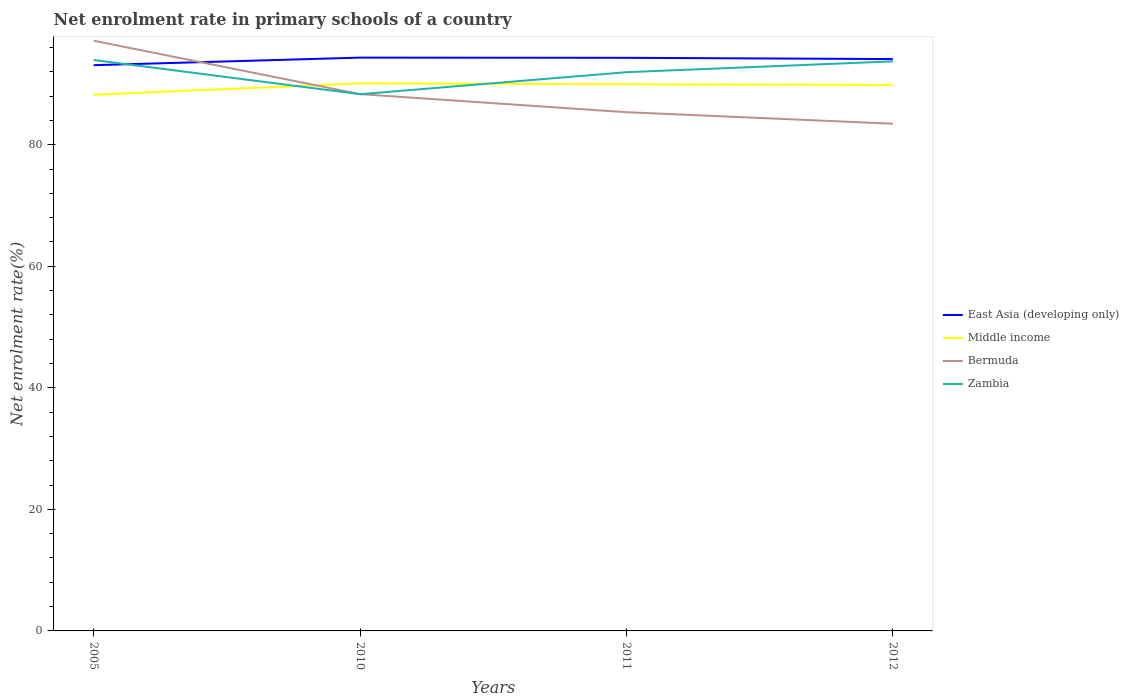Is the number of lines equal to the number of legend labels?
Your response must be concise. Yes. Across all years, what is the maximum net enrolment rate in primary schools in Zambia?
Ensure brevity in your answer.  88.31. What is the total net enrolment rate in primary schools in Middle income in the graph?
Provide a succinct answer. 0.12. What is the difference between the highest and the second highest net enrolment rate in primary schools in Zambia?
Your answer should be compact. 5.63. What is the difference between the highest and the lowest net enrolment rate in primary schools in East Asia (developing only)?
Ensure brevity in your answer.  3. Is the net enrolment rate in primary schools in Bermuda strictly greater than the net enrolment rate in primary schools in East Asia (developing only) over the years?
Your answer should be very brief. No. How many years are there in the graph?
Keep it short and to the point. 4. Are the values on the major ticks of Y-axis written in scientific E-notation?
Ensure brevity in your answer.  No. Where does the legend appear in the graph?
Provide a short and direct response. Center right. How are the legend labels stacked?
Ensure brevity in your answer.  Vertical. What is the title of the graph?
Make the answer very short. Net enrolment rate in primary schools of a country. What is the label or title of the X-axis?
Provide a succinct answer. Years. What is the label or title of the Y-axis?
Offer a very short reply. Net enrolment rate(%). What is the Net enrolment rate(%) of East Asia (developing only) in 2005?
Ensure brevity in your answer.  93.09. What is the Net enrolment rate(%) in Middle income in 2005?
Offer a very short reply. 88.22. What is the Net enrolment rate(%) of Bermuda in 2005?
Your response must be concise. 97.11. What is the Net enrolment rate(%) in Zambia in 2005?
Provide a short and direct response. 93.94. What is the Net enrolment rate(%) in East Asia (developing only) in 2010?
Keep it short and to the point. 94.33. What is the Net enrolment rate(%) in Middle income in 2010?
Your answer should be very brief. 90.09. What is the Net enrolment rate(%) of Bermuda in 2010?
Your answer should be compact. 88.32. What is the Net enrolment rate(%) of Zambia in 2010?
Offer a very short reply. 88.31. What is the Net enrolment rate(%) in East Asia (developing only) in 2011?
Your answer should be compact. 94.3. What is the Net enrolment rate(%) of Middle income in 2011?
Provide a succinct answer. 89.95. What is the Net enrolment rate(%) in Bermuda in 2011?
Your answer should be very brief. 85.35. What is the Net enrolment rate(%) in Zambia in 2011?
Provide a short and direct response. 91.93. What is the Net enrolment rate(%) in East Asia (developing only) in 2012?
Offer a terse response. 94.09. What is the Net enrolment rate(%) of Middle income in 2012?
Provide a short and direct response. 89.83. What is the Net enrolment rate(%) in Bermuda in 2012?
Your answer should be very brief. 83.46. What is the Net enrolment rate(%) in Zambia in 2012?
Keep it short and to the point. 93.72. Across all years, what is the maximum Net enrolment rate(%) in East Asia (developing only)?
Your answer should be compact. 94.33. Across all years, what is the maximum Net enrolment rate(%) in Middle income?
Give a very brief answer. 90.09. Across all years, what is the maximum Net enrolment rate(%) of Bermuda?
Keep it short and to the point. 97.11. Across all years, what is the maximum Net enrolment rate(%) of Zambia?
Provide a succinct answer. 93.94. Across all years, what is the minimum Net enrolment rate(%) in East Asia (developing only)?
Provide a short and direct response. 93.09. Across all years, what is the minimum Net enrolment rate(%) of Middle income?
Offer a very short reply. 88.22. Across all years, what is the minimum Net enrolment rate(%) in Bermuda?
Keep it short and to the point. 83.46. Across all years, what is the minimum Net enrolment rate(%) in Zambia?
Your answer should be compact. 88.31. What is the total Net enrolment rate(%) of East Asia (developing only) in the graph?
Your response must be concise. 375.81. What is the total Net enrolment rate(%) of Middle income in the graph?
Your response must be concise. 358.09. What is the total Net enrolment rate(%) in Bermuda in the graph?
Your answer should be very brief. 354.24. What is the total Net enrolment rate(%) in Zambia in the graph?
Offer a very short reply. 367.9. What is the difference between the Net enrolment rate(%) in East Asia (developing only) in 2005 and that in 2010?
Give a very brief answer. -1.24. What is the difference between the Net enrolment rate(%) in Middle income in 2005 and that in 2010?
Your answer should be compact. -1.87. What is the difference between the Net enrolment rate(%) in Bermuda in 2005 and that in 2010?
Offer a very short reply. 8.79. What is the difference between the Net enrolment rate(%) of Zambia in 2005 and that in 2010?
Offer a very short reply. 5.63. What is the difference between the Net enrolment rate(%) of East Asia (developing only) in 2005 and that in 2011?
Your response must be concise. -1.21. What is the difference between the Net enrolment rate(%) in Middle income in 2005 and that in 2011?
Provide a succinct answer. -1.73. What is the difference between the Net enrolment rate(%) in Bermuda in 2005 and that in 2011?
Your response must be concise. 11.76. What is the difference between the Net enrolment rate(%) of Zambia in 2005 and that in 2011?
Your answer should be compact. 2.01. What is the difference between the Net enrolment rate(%) of East Asia (developing only) in 2005 and that in 2012?
Keep it short and to the point. -1.01. What is the difference between the Net enrolment rate(%) of Middle income in 2005 and that in 2012?
Offer a terse response. -1.61. What is the difference between the Net enrolment rate(%) in Bermuda in 2005 and that in 2012?
Give a very brief answer. 13.65. What is the difference between the Net enrolment rate(%) in Zambia in 2005 and that in 2012?
Give a very brief answer. 0.22. What is the difference between the Net enrolment rate(%) in East Asia (developing only) in 2010 and that in 2011?
Ensure brevity in your answer.  0.03. What is the difference between the Net enrolment rate(%) of Middle income in 2010 and that in 2011?
Make the answer very short. 0.14. What is the difference between the Net enrolment rate(%) in Bermuda in 2010 and that in 2011?
Keep it short and to the point. 2.97. What is the difference between the Net enrolment rate(%) of Zambia in 2010 and that in 2011?
Make the answer very short. -3.62. What is the difference between the Net enrolment rate(%) in East Asia (developing only) in 2010 and that in 2012?
Offer a terse response. 0.24. What is the difference between the Net enrolment rate(%) in Middle income in 2010 and that in 2012?
Make the answer very short. 0.26. What is the difference between the Net enrolment rate(%) of Bermuda in 2010 and that in 2012?
Give a very brief answer. 4.86. What is the difference between the Net enrolment rate(%) of Zambia in 2010 and that in 2012?
Provide a succinct answer. -5.41. What is the difference between the Net enrolment rate(%) in East Asia (developing only) in 2011 and that in 2012?
Your answer should be very brief. 0.21. What is the difference between the Net enrolment rate(%) in Middle income in 2011 and that in 2012?
Give a very brief answer. 0.12. What is the difference between the Net enrolment rate(%) in Bermuda in 2011 and that in 2012?
Make the answer very short. 1.89. What is the difference between the Net enrolment rate(%) of Zambia in 2011 and that in 2012?
Your answer should be very brief. -1.78. What is the difference between the Net enrolment rate(%) of East Asia (developing only) in 2005 and the Net enrolment rate(%) of Middle income in 2010?
Give a very brief answer. 2.99. What is the difference between the Net enrolment rate(%) of East Asia (developing only) in 2005 and the Net enrolment rate(%) of Bermuda in 2010?
Ensure brevity in your answer.  4.76. What is the difference between the Net enrolment rate(%) in East Asia (developing only) in 2005 and the Net enrolment rate(%) in Zambia in 2010?
Keep it short and to the point. 4.77. What is the difference between the Net enrolment rate(%) in Middle income in 2005 and the Net enrolment rate(%) in Bermuda in 2010?
Your answer should be compact. -0.1. What is the difference between the Net enrolment rate(%) in Middle income in 2005 and the Net enrolment rate(%) in Zambia in 2010?
Ensure brevity in your answer.  -0.09. What is the difference between the Net enrolment rate(%) of Bermuda in 2005 and the Net enrolment rate(%) of Zambia in 2010?
Give a very brief answer. 8.8. What is the difference between the Net enrolment rate(%) of East Asia (developing only) in 2005 and the Net enrolment rate(%) of Middle income in 2011?
Your response must be concise. 3.14. What is the difference between the Net enrolment rate(%) in East Asia (developing only) in 2005 and the Net enrolment rate(%) in Bermuda in 2011?
Give a very brief answer. 7.74. What is the difference between the Net enrolment rate(%) of East Asia (developing only) in 2005 and the Net enrolment rate(%) of Zambia in 2011?
Give a very brief answer. 1.15. What is the difference between the Net enrolment rate(%) of Middle income in 2005 and the Net enrolment rate(%) of Bermuda in 2011?
Your answer should be compact. 2.87. What is the difference between the Net enrolment rate(%) of Middle income in 2005 and the Net enrolment rate(%) of Zambia in 2011?
Give a very brief answer. -3.71. What is the difference between the Net enrolment rate(%) of Bermuda in 2005 and the Net enrolment rate(%) of Zambia in 2011?
Keep it short and to the point. 5.18. What is the difference between the Net enrolment rate(%) in East Asia (developing only) in 2005 and the Net enrolment rate(%) in Middle income in 2012?
Give a very brief answer. 3.26. What is the difference between the Net enrolment rate(%) of East Asia (developing only) in 2005 and the Net enrolment rate(%) of Bermuda in 2012?
Provide a short and direct response. 9.63. What is the difference between the Net enrolment rate(%) of East Asia (developing only) in 2005 and the Net enrolment rate(%) of Zambia in 2012?
Offer a terse response. -0.63. What is the difference between the Net enrolment rate(%) in Middle income in 2005 and the Net enrolment rate(%) in Bermuda in 2012?
Give a very brief answer. 4.76. What is the difference between the Net enrolment rate(%) in Middle income in 2005 and the Net enrolment rate(%) in Zambia in 2012?
Provide a succinct answer. -5.5. What is the difference between the Net enrolment rate(%) in Bermuda in 2005 and the Net enrolment rate(%) in Zambia in 2012?
Keep it short and to the point. 3.39. What is the difference between the Net enrolment rate(%) in East Asia (developing only) in 2010 and the Net enrolment rate(%) in Middle income in 2011?
Your answer should be compact. 4.38. What is the difference between the Net enrolment rate(%) of East Asia (developing only) in 2010 and the Net enrolment rate(%) of Bermuda in 2011?
Ensure brevity in your answer.  8.98. What is the difference between the Net enrolment rate(%) of East Asia (developing only) in 2010 and the Net enrolment rate(%) of Zambia in 2011?
Your response must be concise. 2.4. What is the difference between the Net enrolment rate(%) of Middle income in 2010 and the Net enrolment rate(%) of Bermuda in 2011?
Give a very brief answer. 4.74. What is the difference between the Net enrolment rate(%) in Middle income in 2010 and the Net enrolment rate(%) in Zambia in 2011?
Make the answer very short. -1.84. What is the difference between the Net enrolment rate(%) of Bermuda in 2010 and the Net enrolment rate(%) of Zambia in 2011?
Provide a short and direct response. -3.61. What is the difference between the Net enrolment rate(%) in East Asia (developing only) in 2010 and the Net enrolment rate(%) in Middle income in 2012?
Keep it short and to the point. 4.5. What is the difference between the Net enrolment rate(%) in East Asia (developing only) in 2010 and the Net enrolment rate(%) in Bermuda in 2012?
Your answer should be very brief. 10.87. What is the difference between the Net enrolment rate(%) in East Asia (developing only) in 2010 and the Net enrolment rate(%) in Zambia in 2012?
Provide a short and direct response. 0.61. What is the difference between the Net enrolment rate(%) in Middle income in 2010 and the Net enrolment rate(%) in Bermuda in 2012?
Give a very brief answer. 6.63. What is the difference between the Net enrolment rate(%) of Middle income in 2010 and the Net enrolment rate(%) of Zambia in 2012?
Make the answer very short. -3.62. What is the difference between the Net enrolment rate(%) in Bermuda in 2010 and the Net enrolment rate(%) in Zambia in 2012?
Your answer should be very brief. -5.39. What is the difference between the Net enrolment rate(%) in East Asia (developing only) in 2011 and the Net enrolment rate(%) in Middle income in 2012?
Give a very brief answer. 4.47. What is the difference between the Net enrolment rate(%) of East Asia (developing only) in 2011 and the Net enrolment rate(%) of Bermuda in 2012?
Provide a short and direct response. 10.84. What is the difference between the Net enrolment rate(%) in East Asia (developing only) in 2011 and the Net enrolment rate(%) in Zambia in 2012?
Offer a very short reply. 0.58. What is the difference between the Net enrolment rate(%) in Middle income in 2011 and the Net enrolment rate(%) in Bermuda in 2012?
Provide a short and direct response. 6.49. What is the difference between the Net enrolment rate(%) in Middle income in 2011 and the Net enrolment rate(%) in Zambia in 2012?
Your answer should be compact. -3.77. What is the difference between the Net enrolment rate(%) of Bermuda in 2011 and the Net enrolment rate(%) of Zambia in 2012?
Offer a very short reply. -8.37. What is the average Net enrolment rate(%) of East Asia (developing only) per year?
Your response must be concise. 93.95. What is the average Net enrolment rate(%) of Middle income per year?
Give a very brief answer. 89.52. What is the average Net enrolment rate(%) in Bermuda per year?
Give a very brief answer. 88.56. What is the average Net enrolment rate(%) in Zambia per year?
Provide a succinct answer. 91.98. In the year 2005, what is the difference between the Net enrolment rate(%) in East Asia (developing only) and Net enrolment rate(%) in Middle income?
Offer a terse response. 4.87. In the year 2005, what is the difference between the Net enrolment rate(%) in East Asia (developing only) and Net enrolment rate(%) in Bermuda?
Provide a succinct answer. -4.03. In the year 2005, what is the difference between the Net enrolment rate(%) of East Asia (developing only) and Net enrolment rate(%) of Zambia?
Offer a terse response. -0.86. In the year 2005, what is the difference between the Net enrolment rate(%) in Middle income and Net enrolment rate(%) in Bermuda?
Your answer should be very brief. -8.89. In the year 2005, what is the difference between the Net enrolment rate(%) in Middle income and Net enrolment rate(%) in Zambia?
Your answer should be very brief. -5.72. In the year 2005, what is the difference between the Net enrolment rate(%) of Bermuda and Net enrolment rate(%) of Zambia?
Provide a succinct answer. 3.17. In the year 2010, what is the difference between the Net enrolment rate(%) in East Asia (developing only) and Net enrolment rate(%) in Middle income?
Keep it short and to the point. 4.24. In the year 2010, what is the difference between the Net enrolment rate(%) in East Asia (developing only) and Net enrolment rate(%) in Bermuda?
Give a very brief answer. 6.01. In the year 2010, what is the difference between the Net enrolment rate(%) of East Asia (developing only) and Net enrolment rate(%) of Zambia?
Give a very brief answer. 6.02. In the year 2010, what is the difference between the Net enrolment rate(%) in Middle income and Net enrolment rate(%) in Bermuda?
Your answer should be very brief. 1.77. In the year 2010, what is the difference between the Net enrolment rate(%) in Middle income and Net enrolment rate(%) in Zambia?
Provide a succinct answer. 1.78. In the year 2010, what is the difference between the Net enrolment rate(%) in Bermuda and Net enrolment rate(%) in Zambia?
Give a very brief answer. 0.01. In the year 2011, what is the difference between the Net enrolment rate(%) of East Asia (developing only) and Net enrolment rate(%) of Middle income?
Your response must be concise. 4.35. In the year 2011, what is the difference between the Net enrolment rate(%) of East Asia (developing only) and Net enrolment rate(%) of Bermuda?
Make the answer very short. 8.95. In the year 2011, what is the difference between the Net enrolment rate(%) of East Asia (developing only) and Net enrolment rate(%) of Zambia?
Ensure brevity in your answer.  2.37. In the year 2011, what is the difference between the Net enrolment rate(%) of Middle income and Net enrolment rate(%) of Bermuda?
Give a very brief answer. 4.6. In the year 2011, what is the difference between the Net enrolment rate(%) in Middle income and Net enrolment rate(%) in Zambia?
Provide a short and direct response. -1.98. In the year 2011, what is the difference between the Net enrolment rate(%) in Bermuda and Net enrolment rate(%) in Zambia?
Offer a terse response. -6.58. In the year 2012, what is the difference between the Net enrolment rate(%) in East Asia (developing only) and Net enrolment rate(%) in Middle income?
Provide a succinct answer. 4.26. In the year 2012, what is the difference between the Net enrolment rate(%) of East Asia (developing only) and Net enrolment rate(%) of Bermuda?
Give a very brief answer. 10.63. In the year 2012, what is the difference between the Net enrolment rate(%) of East Asia (developing only) and Net enrolment rate(%) of Zambia?
Your answer should be very brief. 0.38. In the year 2012, what is the difference between the Net enrolment rate(%) of Middle income and Net enrolment rate(%) of Bermuda?
Keep it short and to the point. 6.37. In the year 2012, what is the difference between the Net enrolment rate(%) in Middle income and Net enrolment rate(%) in Zambia?
Ensure brevity in your answer.  -3.89. In the year 2012, what is the difference between the Net enrolment rate(%) in Bermuda and Net enrolment rate(%) in Zambia?
Provide a short and direct response. -10.26. What is the ratio of the Net enrolment rate(%) in East Asia (developing only) in 2005 to that in 2010?
Your answer should be compact. 0.99. What is the ratio of the Net enrolment rate(%) in Middle income in 2005 to that in 2010?
Give a very brief answer. 0.98. What is the ratio of the Net enrolment rate(%) of Bermuda in 2005 to that in 2010?
Your answer should be very brief. 1.1. What is the ratio of the Net enrolment rate(%) in Zambia in 2005 to that in 2010?
Offer a very short reply. 1.06. What is the ratio of the Net enrolment rate(%) of East Asia (developing only) in 2005 to that in 2011?
Make the answer very short. 0.99. What is the ratio of the Net enrolment rate(%) in Middle income in 2005 to that in 2011?
Provide a short and direct response. 0.98. What is the ratio of the Net enrolment rate(%) in Bermuda in 2005 to that in 2011?
Offer a terse response. 1.14. What is the ratio of the Net enrolment rate(%) in Zambia in 2005 to that in 2011?
Give a very brief answer. 1.02. What is the ratio of the Net enrolment rate(%) in East Asia (developing only) in 2005 to that in 2012?
Offer a very short reply. 0.99. What is the ratio of the Net enrolment rate(%) of Middle income in 2005 to that in 2012?
Your answer should be compact. 0.98. What is the ratio of the Net enrolment rate(%) in Bermuda in 2005 to that in 2012?
Make the answer very short. 1.16. What is the ratio of the Net enrolment rate(%) of Zambia in 2005 to that in 2012?
Offer a very short reply. 1. What is the ratio of the Net enrolment rate(%) in Bermuda in 2010 to that in 2011?
Provide a succinct answer. 1.03. What is the ratio of the Net enrolment rate(%) in Zambia in 2010 to that in 2011?
Offer a terse response. 0.96. What is the ratio of the Net enrolment rate(%) of Middle income in 2010 to that in 2012?
Provide a short and direct response. 1. What is the ratio of the Net enrolment rate(%) of Bermuda in 2010 to that in 2012?
Your answer should be very brief. 1.06. What is the ratio of the Net enrolment rate(%) of Zambia in 2010 to that in 2012?
Give a very brief answer. 0.94. What is the ratio of the Net enrolment rate(%) of Bermuda in 2011 to that in 2012?
Give a very brief answer. 1.02. What is the difference between the highest and the second highest Net enrolment rate(%) of East Asia (developing only)?
Your answer should be compact. 0.03. What is the difference between the highest and the second highest Net enrolment rate(%) of Middle income?
Give a very brief answer. 0.14. What is the difference between the highest and the second highest Net enrolment rate(%) in Bermuda?
Offer a very short reply. 8.79. What is the difference between the highest and the second highest Net enrolment rate(%) of Zambia?
Your answer should be compact. 0.22. What is the difference between the highest and the lowest Net enrolment rate(%) in East Asia (developing only)?
Your answer should be compact. 1.24. What is the difference between the highest and the lowest Net enrolment rate(%) of Middle income?
Offer a terse response. 1.87. What is the difference between the highest and the lowest Net enrolment rate(%) of Bermuda?
Offer a terse response. 13.65. What is the difference between the highest and the lowest Net enrolment rate(%) of Zambia?
Your response must be concise. 5.63. 